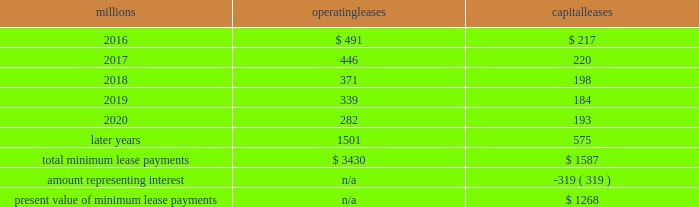We maintain and operate the assets based on contractual obligations within the lease arrangements , which set specific guidelines consistent within the railroad industry .
As such , we have no control over activities that could materially impact the fair value of the leased assets .
We do not hold the power to direct the activities of the vies and , therefore , do not control the ongoing activities that have a significant impact on the economic performance of the vies .
Additionally , we do not have the obligation to absorb losses of the vies or the right to receive benefits of the vies that could potentially be significant to the we are not considered to be the primary beneficiary and do not consolidate these vies because our actions and decisions do not have the most significant effect on the vie 2019s performance and our fixed-price purchase options are not considered to be potentially significant to the vies .
The future minimum lease payments associated with the vie leases totaled $ 2.6 billion as of december 31 , 2015 .
17 .
Leases we lease certain locomotives , freight cars , and other property .
The consolidated statements of financial position as of december 31 , 2015 and 2014 included $ 2273 million , net of $ 1189 million of accumulated depreciation , and $ 2454 million , net of $ 1210 million of accumulated depreciation , respectively , for properties held under capital leases .
A charge to income resulting from the depreciation for assets held under capital leases is included within depreciation expense in our consolidated statements of income .
Future minimum lease payments for operating and capital leases with initial or remaining non-cancelable lease terms in excess of one year as of december 31 , 2015 , were as follows : millions operating leases capital leases .
Approximately 95% ( 95 % ) of capital lease payments relate to locomotives .
Rent expense for operating leases with terms exceeding one month was $ 590 million in 2015 , $ 593 million in 2014 , and $ 618 million in 2013 .
When cash rental payments are not made on a straight-line basis , we recognize variable rental expense on a straight-line basis over the lease term .
Contingent rentals and sub-rentals are not significant .
18 .
Commitments and contingencies asserted and unasserted claims 2013 various claims and lawsuits are pending against us and certain of our subsidiaries .
We cannot fully determine the effect of all asserted and unasserted claims on our consolidated results of operations , financial condition , or liquidity .
To the extent possible , we have recorded a liability where asserted and unasserted claims are considered probable and where such claims can be reasonably estimated .
We do not expect that any known lawsuits , claims , environmental costs , commitments , contingent liabilities , or guarantees will have a material adverse effect on our consolidated results of operations , financial condition , or liquidity after taking into account liabilities and insurance recoveries previously recorded for these matters .
Personal injury 2013 the cost of personal injuries to employees and others related to our activities is charged to expense based on estimates of the ultimate cost and number of incidents each year .
We use an actuarial analysis to measure the expense and liability , including unasserted claims .
The federal employers 2019 liability act ( fela ) governs compensation for work-related accidents .
Under fela , damages are assessed based on a finding of fault through litigation or out-of-court settlements .
We offer a comprehensive variety of services and rehabilitation programs for employees who are injured at work .
Our personal injury liability is not discounted to present value due to the uncertainty surrounding the timing of future payments .
Approximately 94% ( 94 % ) of the recorded liability is related to asserted claims and .
What percentage of total minimum lease payments are capital leases? 
Computations: (1587 / (3430 + 1587))
Answer: 0.31632. 